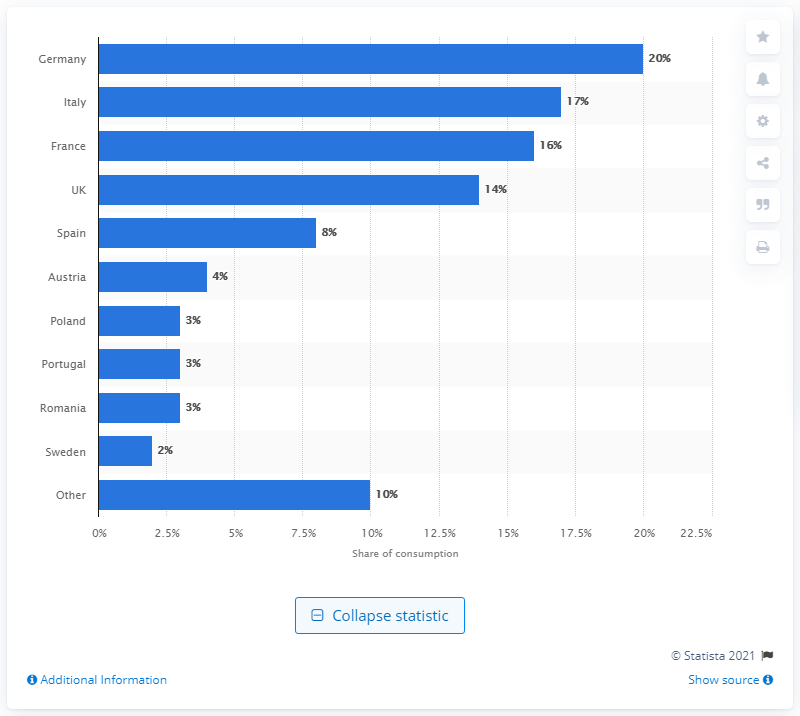Draw attention to some important aspects in this diagram. According to data from 2014, Germany accounted for approximately XXX% of footwear consumption in the EU. According to data from 2014, Germany had the highest share of footwear consumption among all countries. 